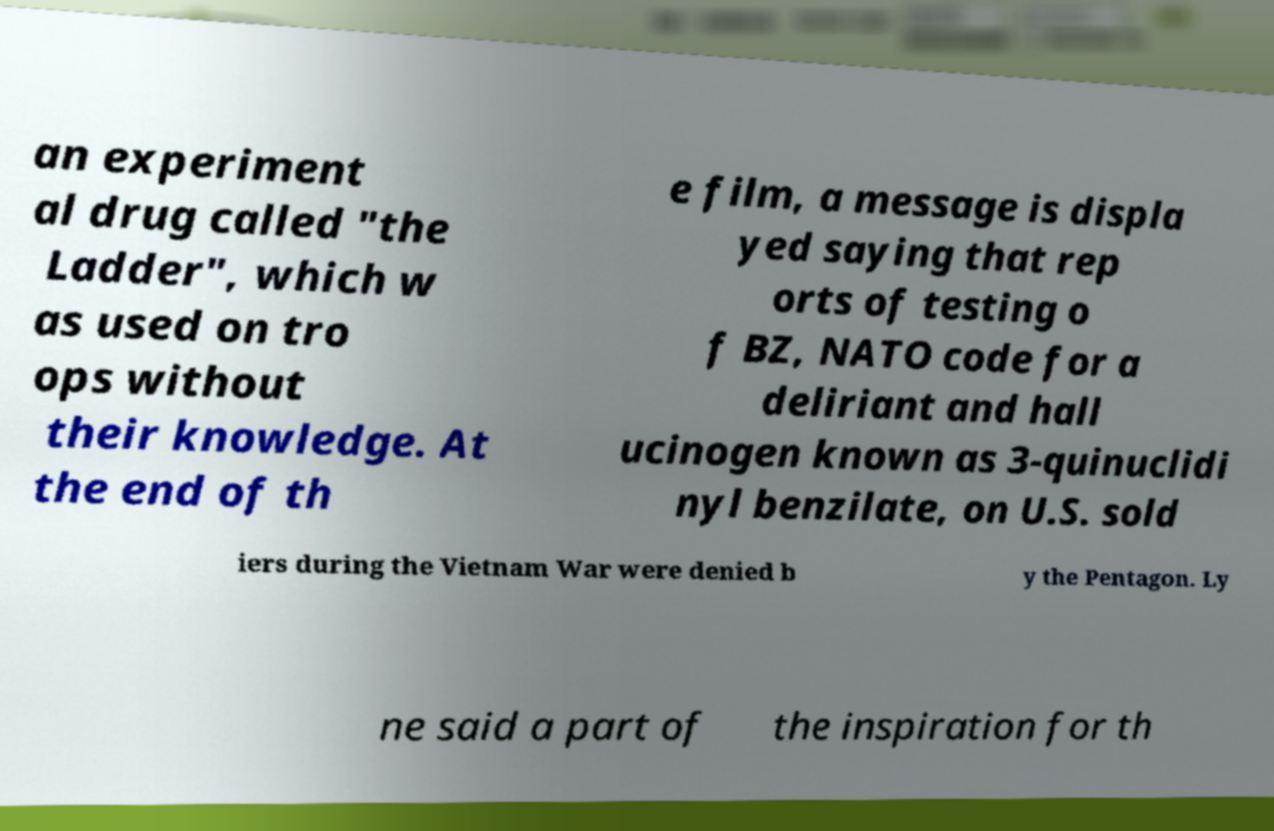What messages or text are displayed in this image? I need them in a readable, typed format. an experiment al drug called "the Ladder", which w as used on tro ops without their knowledge. At the end of th e film, a message is displa yed saying that rep orts of testing o f BZ, NATO code for a deliriant and hall ucinogen known as 3-quinuclidi nyl benzilate, on U.S. sold iers during the Vietnam War were denied b y the Pentagon. Ly ne said a part of the inspiration for th 